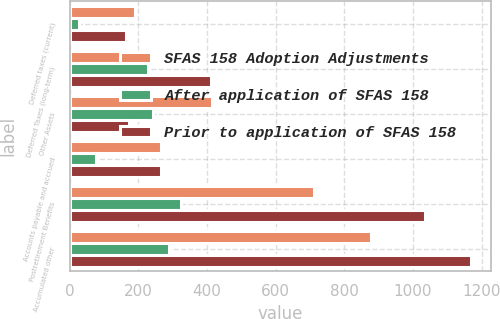Convert chart to OTSL. <chart><loc_0><loc_0><loc_500><loc_500><stacked_bar_chart><ecel><fcel>Deferred taxes (current)<fcel>Deferred Taxes (long-term)<fcel>Other Assets<fcel>Accounts payable and accrued<fcel>Postretirement Benefits<fcel>Accumulated other<nl><fcel>SFAS 158 Adoption Adjustments<fcel>191<fcel>186<fcel>416<fcel>266.5<fcel>713<fcel>879<nl><fcel>After application of SFAS 158<fcel>28<fcel>227<fcel>243<fcel>77<fcel>323<fcel>290<nl><fcel>Prior to application of SFAS 158<fcel>163<fcel>413<fcel>173<fcel>266.5<fcel>1036<fcel>1169<nl></chart> 